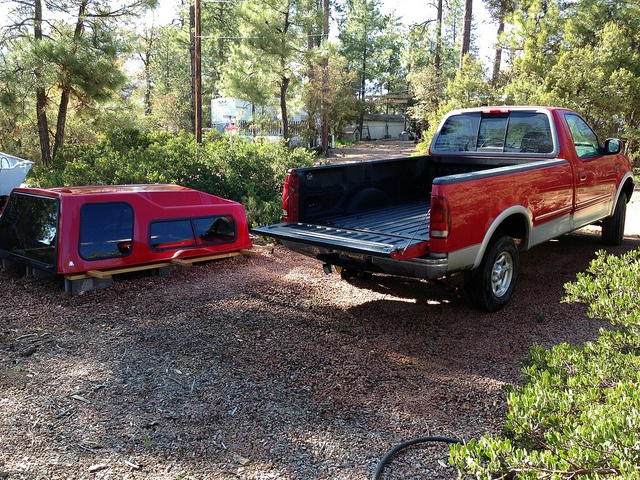Describe the objects in this image and their specific colors. I can see a truck in ivory, black, gray, maroon, and brown tones in this image. 